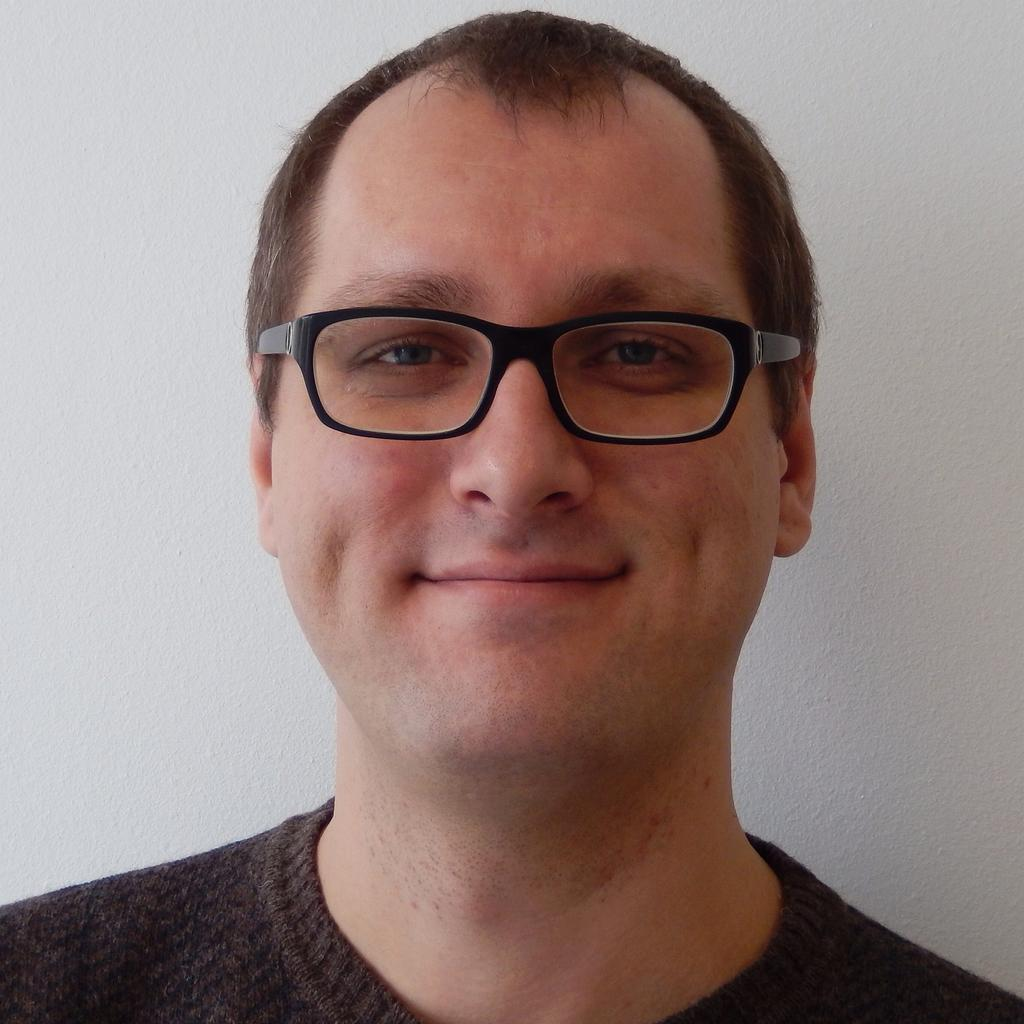Who is the main subject in the image? There is a man in the center of the image. What is the man wearing in the image? The man is wearing glasses in the image. What can be seen in the background of the image? There is a wall in the background of the image. What type of mist can be seen surrounding the man in the image? There is no mist present in the image; it is a clear image of a man wearing glasses with a wall in the background. 